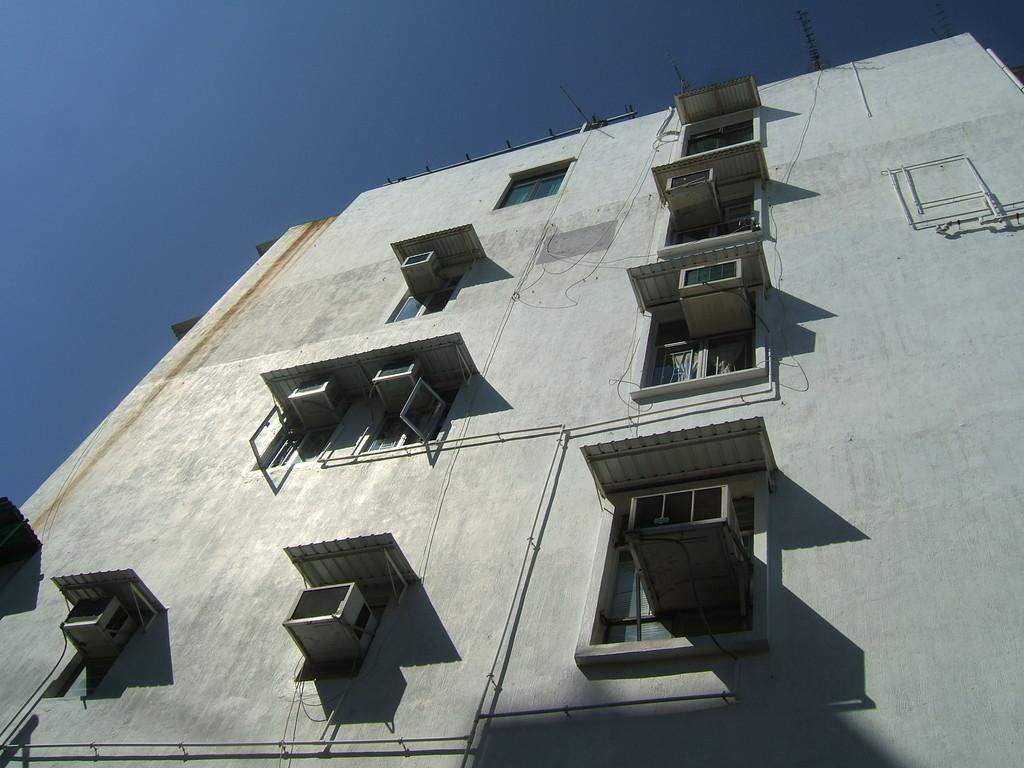What is the color of the building in the image? The building in the image is white-colored. What can be seen in the background of the image? The sky is visible in the image. What architectural features are present on the building? There are windows in the building. What type of beef is being served in the image? There is no beef present in the image; it features a white-colored building with windows and a visible sky. 